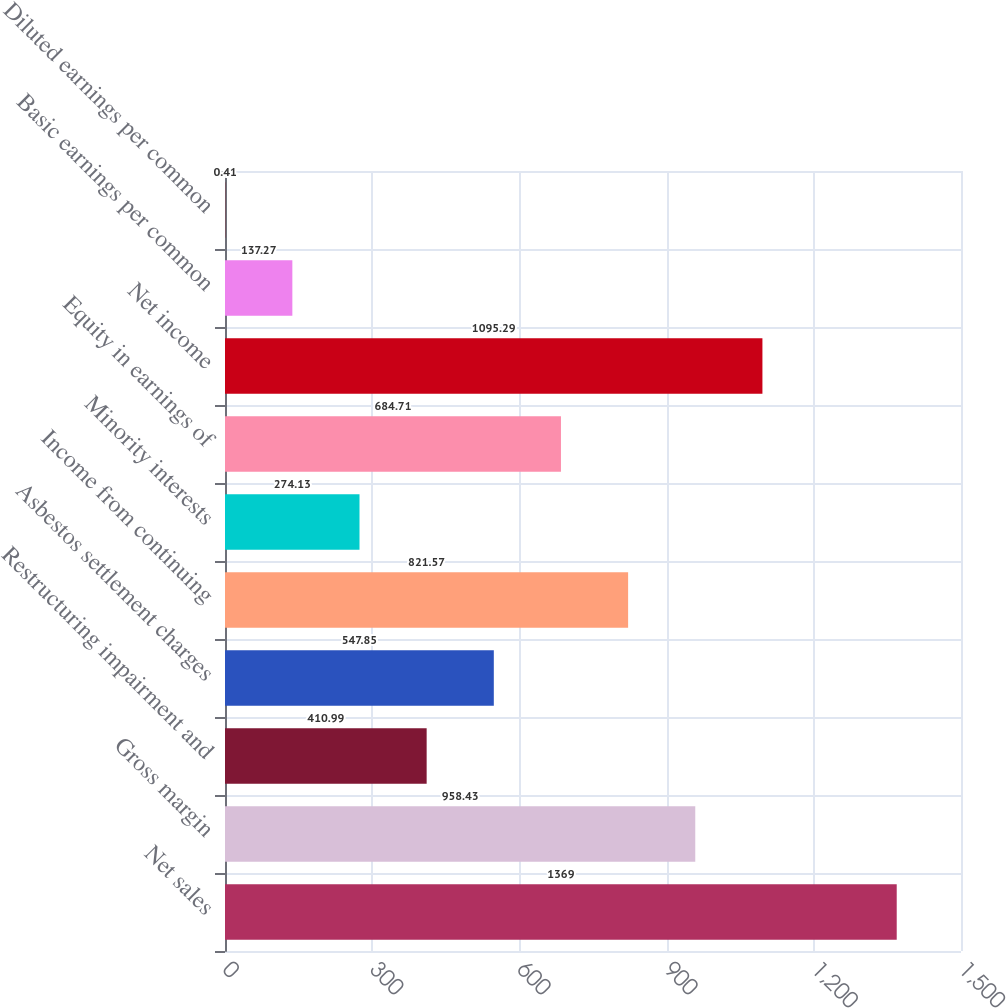<chart> <loc_0><loc_0><loc_500><loc_500><bar_chart><fcel>Net sales<fcel>Gross margin<fcel>Restructuring impairment and<fcel>Asbestos settlement charges<fcel>Income from continuing<fcel>Minority interests<fcel>Equity in earnings of<fcel>Net income<fcel>Basic earnings per common<fcel>Diluted earnings per common<nl><fcel>1369<fcel>958.43<fcel>410.99<fcel>547.85<fcel>821.57<fcel>274.13<fcel>684.71<fcel>1095.29<fcel>137.27<fcel>0.41<nl></chart> 